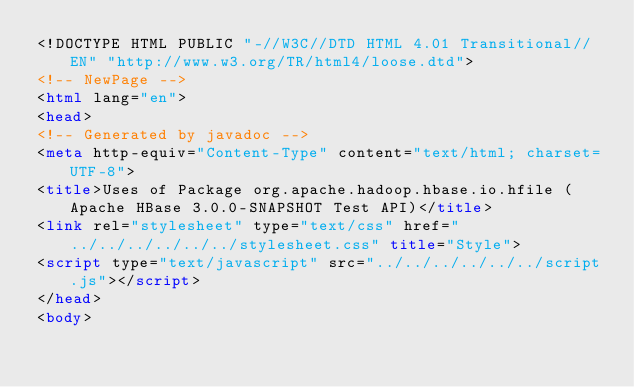Convert code to text. <code><loc_0><loc_0><loc_500><loc_500><_HTML_><!DOCTYPE HTML PUBLIC "-//W3C//DTD HTML 4.01 Transitional//EN" "http://www.w3.org/TR/html4/loose.dtd">
<!-- NewPage -->
<html lang="en">
<head>
<!-- Generated by javadoc -->
<meta http-equiv="Content-Type" content="text/html; charset=UTF-8">
<title>Uses of Package org.apache.hadoop.hbase.io.hfile (Apache HBase 3.0.0-SNAPSHOT Test API)</title>
<link rel="stylesheet" type="text/css" href="../../../../../../stylesheet.css" title="Style">
<script type="text/javascript" src="../../../../../../script.js"></script>
</head>
<body></code> 